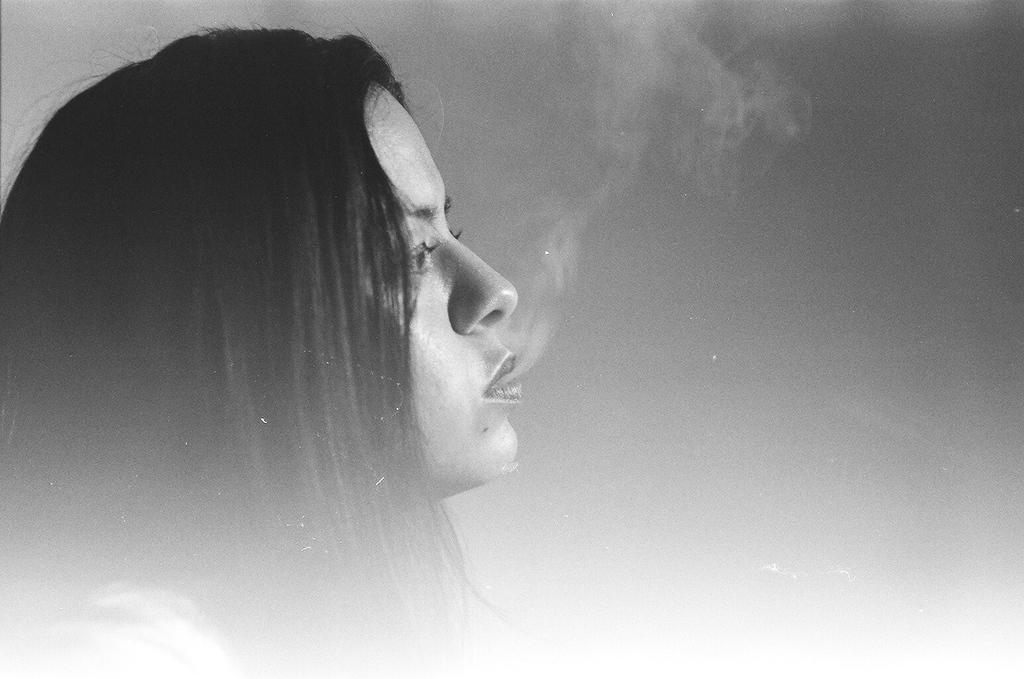Who is present in the image? There is a lady in the image. What type of form does the lady's leg have in the image? There is no specific information about the lady's leg in the image, so it is not possible to answer that question. 